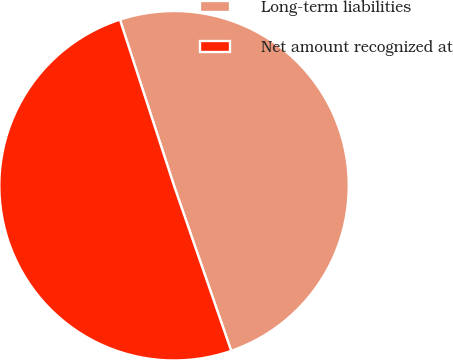Convert chart. <chart><loc_0><loc_0><loc_500><loc_500><pie_chart><fcel>Long-term liabilities<fcel>Net amount recognized at<nl><fcel>49.71%<fcel>50.29%<nl></chart> 